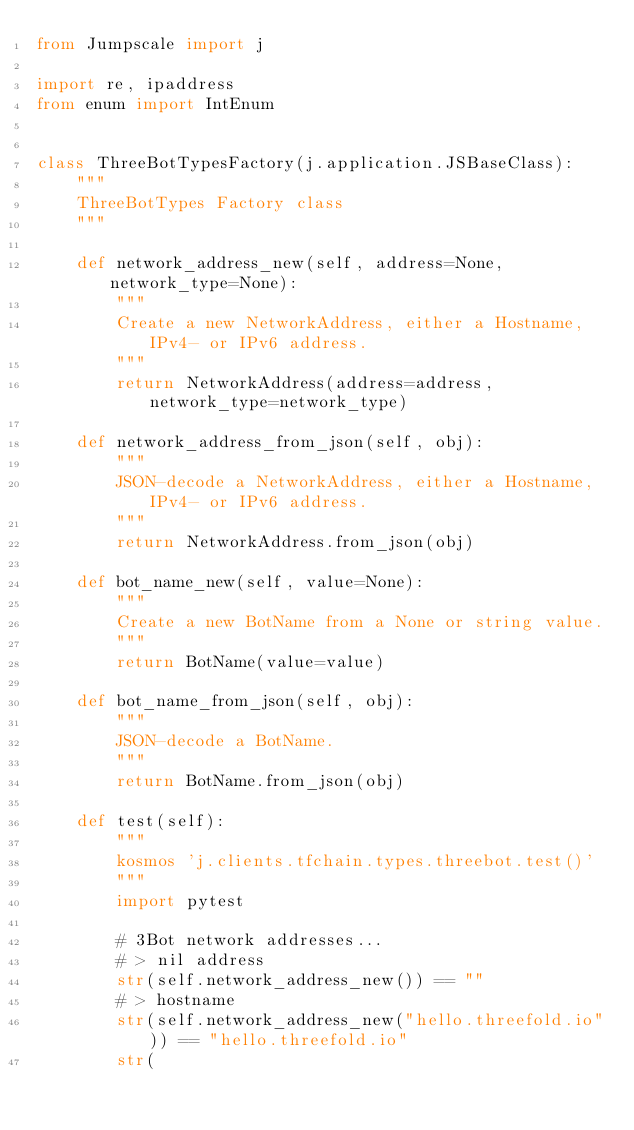Convert code to text. <code><loc_0><loc_0><loc_500><loc_500><_Python_>from Jumpscale import j

import re, ipaddress
from enum import IntEnum


class ThreeBotTypesFactory(j.application.JSBaseClass):
    """
    ThreeBotTypes Factory class
    """

    def network_address_new(self, address=None, network_type=None):
        """
        Create a new NetworkAddress, either a Hostname, IPv4- or IPv6 address.
        """
        return NetworkAddress(address=address, network_type=network_type)

    def network_address_from_json(self, obj):
        """
        JSON-decode a NetworkAddress, either a Hostname, IPv4- or IPv6 address.
        """
        return NetworkAddress.from_json(obj)

    def bot_name_new(self, value=None):
        """
        Create a new BotName from a None or string value.
        """
        return BotName(value=value)

    def bot_name_from_json(self, obj):
        """
        JSON-decode a BotName.
        """
        return BotName.from_json(obj)

    def test(self):
        """
        kosmos 'j.clients.tfchain.types.threebot.test()'
        """
        import pytest

        # 3Bot network addresses...
        # > nil address
        str(self.network_address_new()) == ""
        # > hostname
        str(self.network_address_new("hello.threefold.io")) == "hello.threefold.io"
        str(</code> 